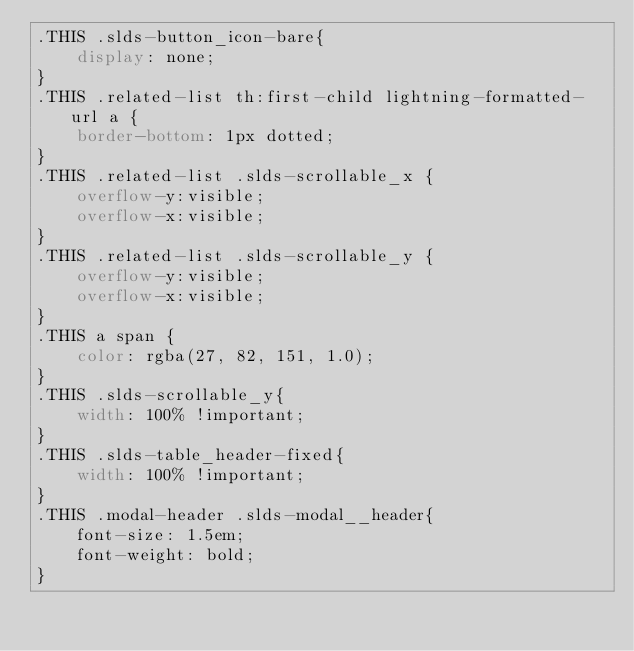<code> <loc_0><loc_0><loc_500><loc_500><_CSS_>.THIS .slds-button_icon-bare{
    display: none;
}
.THIS .related-list th:first-child lightning-formatted-url a {
    border-bottom: 1px dotted;
}
.THIS .related-list .slds-scrollable_x {
    overflow-y:visible;
    overflow-x:visible;
}
.THIS .related-list .slds-scrollable_y {
    overflow-y:visible;
    overflow-x:visible;
}
.THIS a span {
    color: rgba(27, 82, 151, 1.0); 
}
.THIS .slds-scrollable_y{
    width: 100% !important;
}
.THIS .slds-table_header-fixed{
    width: 100% !important;
}
.THIS .modal-header .slds-modal__header{
    font-size: 1.5em;
	font-weight: bold;    
}</code> 